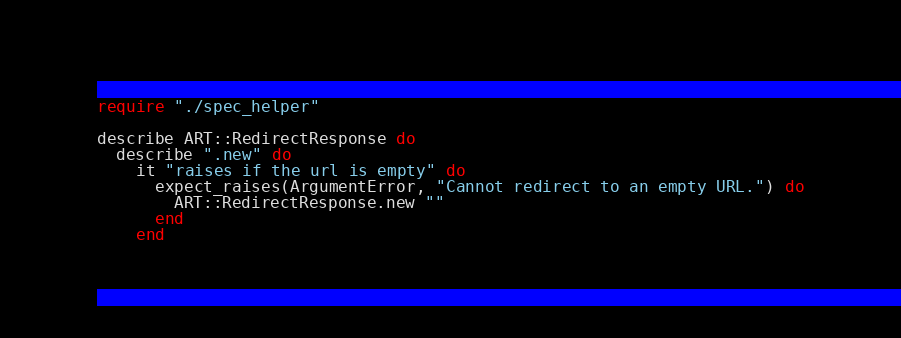<code> <loc_0><loc_0><loc_500><loc_500><_Crystal_>require "./spec_helper"

describe ART::RedirectResponse do
  describe ".new" do
    it "raises if the url is empty" do
      expect_raises(ArgumentError, "Cannot redirect to an empty URL.") do
        ART::RedirectResponse.new ""
      end
    end
</code> 